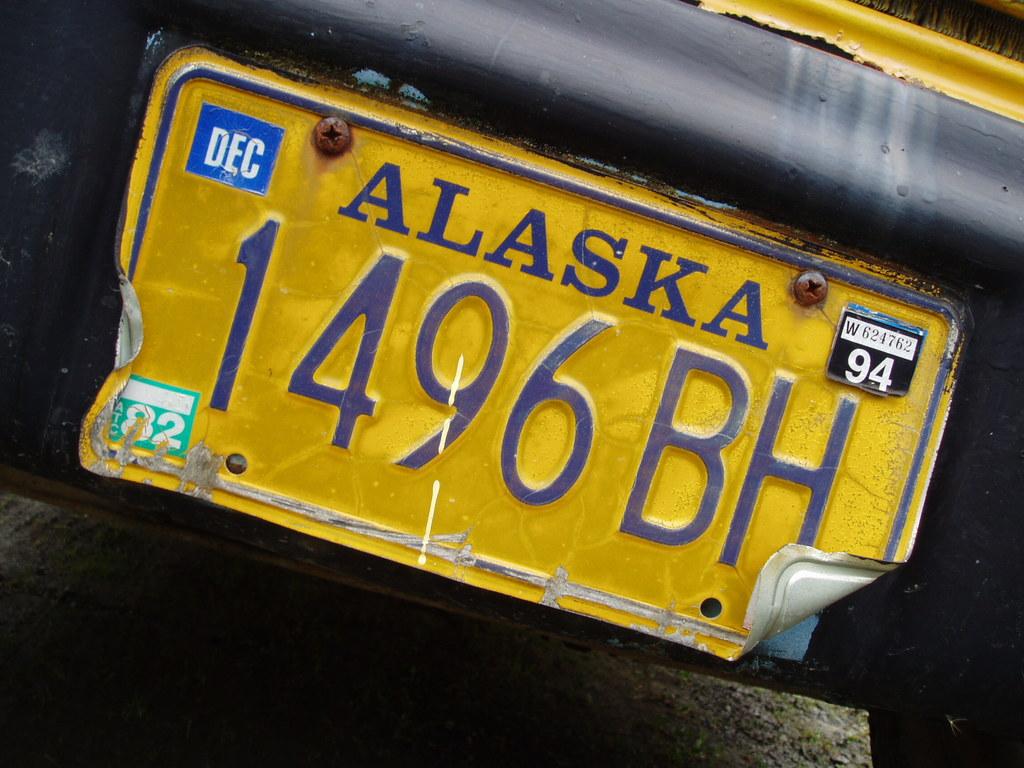What state is on the license plate?
Offer a very short reply. Alaska. What is the license plate number?
Your answer should be very brief. 1496bh. 